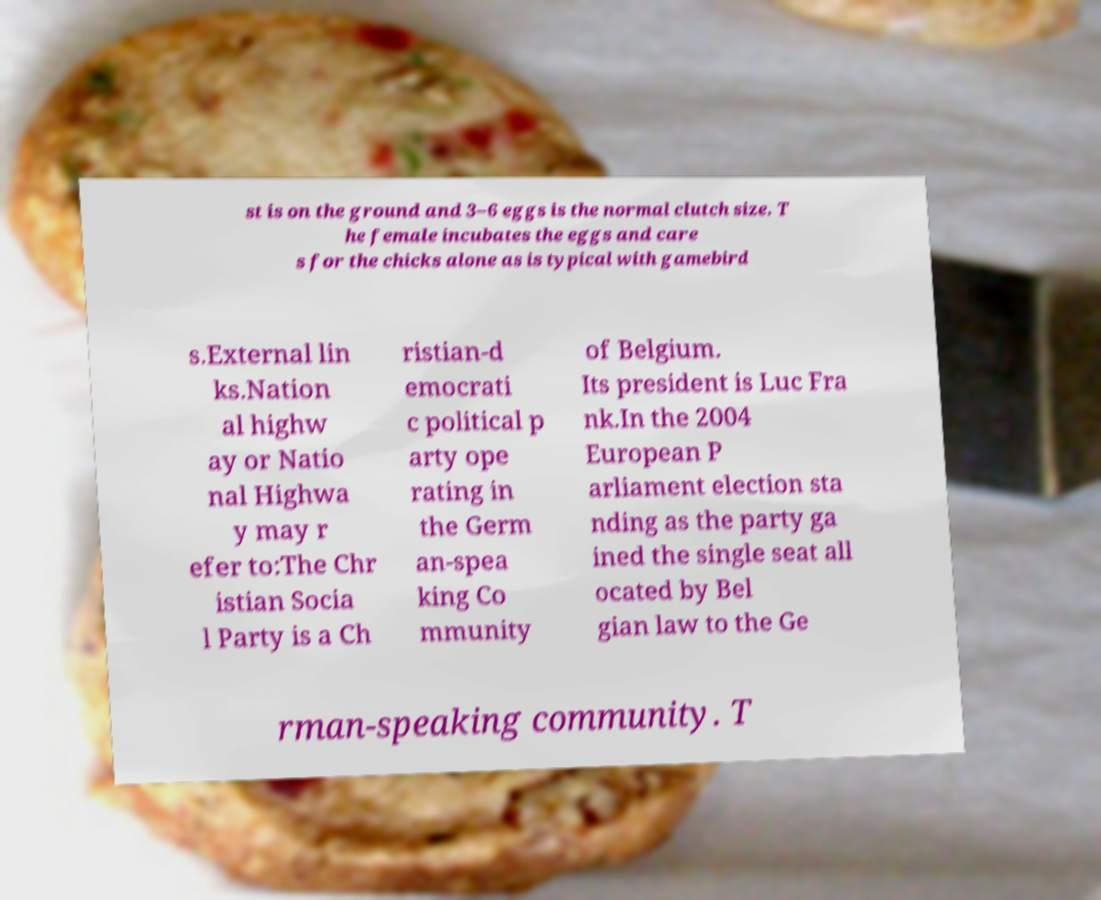Please read and relay the text visible in this image. What does it say? st is on the ground and 3–6 eggs is the normal clutch size. T he female incubates the eggs and care s for the chicks alone as is typical with gamebird s.External lin ks.Nation al highw ay or Natio nal Highwa y may r efer to:The Chr istian Socia l Party is a Ch ristian-d emocrati c political p arty ope rating in the Germ an-spea king Co mmunity of Belgium. Its president is Luc Fra nk.In the 2004 European P arliament election sta nding as the party ga ined the single seat all ocated by Bel gian law to the Ge rman-speaking community. T 